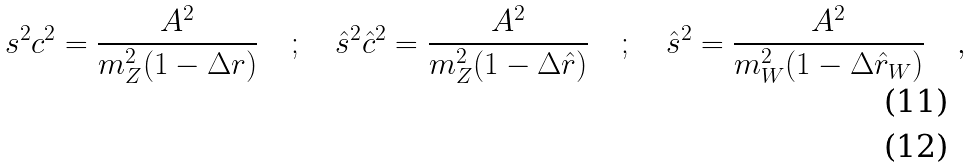<formula> <loc_0><loc_0><loc_500><loc_500>s ^ { 2 } c ^ { 2 } = \frac { A ^ { 2 } } { m _ { Z } ^ { 2 } ( 1 - \Delta r ) } \quad ; \quad \hat { s } ^ { 2 } \hat { c } ^ { 2 } = \frac { A ^ { 2 } } { m _ { Z } ^ { 2 } ( 1 - \Delta \hat { r } ) } \quad ; \quad \hat { s } ^ { 2 } = \frac { A ^ { 2 } } { m _ { W } ^ { 2 } ( 1 - \Delta \hat { r } _ { W } ) } \quad , \\</formula> 